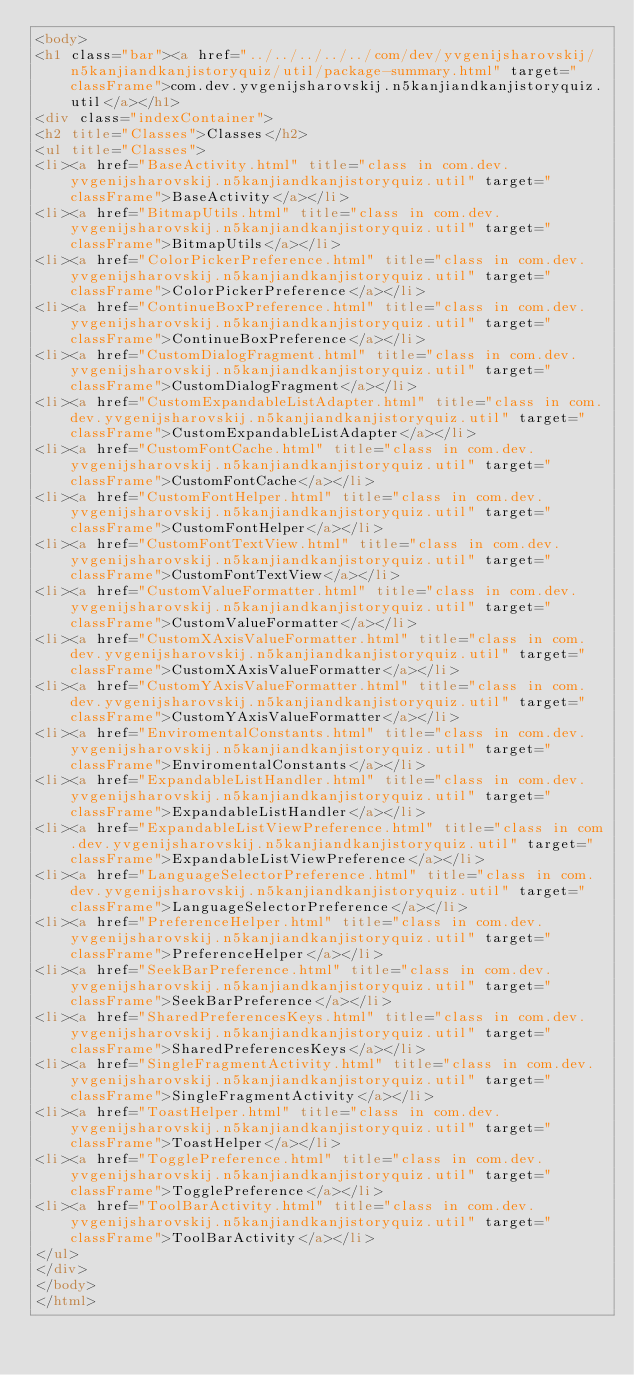Convert code to text. <code><loc_0><loc_0><loc_500><loc_500><_HTML_><body>
<h1 class="bar"><a href="../../../../../com/dev/yvgenijsharovskij/n5kanjiandkanjistoryquiz/util/package-summary.html" target="classFrame">com.dev.yvgenijsharovskij.n5kanjiandkanjistoryquiz.util</a></h1>
<div class="indexContainer">
<h2 title="Classes">Classes</h2>
<ul title="Classes">
<li><a href="BaseActivity.html" title="class in com.dev.yvgenijsharovskij.n5kanjiandkanjistoryquiz.util" target="classFrame">BaseActivity</a></li>
<li><a href="BitmapUtils.html" title="class in com.dev.yvgenijsharovskij.n5kanjiandkanjistoryquiz.util" target="classFrame">BitmapUtils</a></li>
<li><a href="ColorPickerPreference.html" title="class in com.dev.yvgenijsharovskij.n5kanjiandkanjistoryquiz.util" target="classFrame">ColorPickerPreference</a></li>
<li><a href="ContinueBoxPreference.html" title="class in com.dev.yvgenijsharovskij.n5kanjiandkanjistoryquiz.util" target="classFrame">ContinueBoxPreference</a></li>
<li><a href="CustomDialogFragment.html" title="class in com.dev.yvgenijsharovskij.n5kanjiandkanjistoryquiz.util" target="classFrame">CustomDialogFragment</a></li>
<li><a href="CustomExpandableListAdapter.html" title="class in com.dev.yvgenijsharovskij.n5kanjiandkanjistoryquiz.util" target="classFrame">CustomExpandableListAdapter</a></li>
<li><a href="CustomFontCache.html" title="class in com.dev.yvgenijsharovskij.n5kanjiandkanjistoryquiz.util" target="classFrame">CustomFontCache</a></li>
<li><a href="CustomFontHelper.html" title="class in com.dev.yvgenijsharovskij.n5kanjiandkanjistoryquiz.util" target="classFrame">CustomFontHelper</a></li>
<li><a href="CustomFontTextView.html" title="class in com.dev.yvgenijsharovskij.n5kanjiandkanjistoryquiz.util" target="classFrame">CustomFontTextView</a></li>
<li><a href="CustomValueFormatter.html" title="class in com.dev.yvgenijsharovskij.n5kanjiandkanjistoryquiz.util" target="classFrame">CustomValueFormatter</a></li>
<li><a href="CustomXAxisValueFormatter.html" title="class in com.dev.yvgenijsharovskij.n5kanjiandkanjistoryquiz.util" target="classFrame">CustomXAxisValueFormatter</a></li>
<li><a href="CustomYAxisValueFormatter.html" title="class in com.dev.yvgenijsharovskij.n5kanjiandkanjistoryquiz.util" target="classFrame">CustomYAxisValueFormatter</a></li>
<li><a href="EnviromentalConstants.html" title="class in com.dev.yvgenijsharovskij.n5kanjiandkanjistoryquiz.util" target="classFrame">EnviromentalConstants</a></li>
<li><a href="ExpandableListHandler.html" title="class in com.dev.yvgenijsharovskij.n5kanjiandkanjistoryquiz.util" target="classFrame">ExpandableListHandler</a></li>
<li><a href="ExpandableListViewPreference.html" title="class in com.dev.yvgenijsharovskij.n5kanjiandkanjistoryquiz.util" target="classFrame">ExpandableListViewPreference</a></li>
<li><a href="LanguageSelectorPreference.html" title="class in com.dev.yvgenijsharovskij.n5kanjiandkanjistoryquiz.util" target="classFrame">LanguageSelectorPreference</a></li>
<li><a href="PreferenceHelper.html" title="class in com.dev.yvgenijsharovskij.n5kanjiandkanjistoryquiz.util" target="classFrame">PreferenceHelper</a></li>
<li><a href="SeekBarPreference.html" title="class in com.dev.yvgenijsharovskij.n5kanjiandkanjistoryquiz.util" target="classFrame">SeekBarPreference</a></li>
<li><a href="SharedPreferencesKeys.html" title="class in com.dev.yvgenijsharovskij.n5kanjiandkanjistoryquiz.util" target="classFrame">SharedPreferencesKeys</a></li>
<li><a href="SingleFragmentActivity.html" title="class in com.dev.yvgenijsharovskij.n5kanjiandkanjistoryquiz.util" target="classFrame">SingleFragmentActivity</a></li>
<li><a href="ToastHelper.html" title="class in com.dev.yvgenijsharovskij.n5kanjiandkanjistoryquiz.util" target="classFrame">ToastHelper</a></li>
<li><a href="TogglePreference.html" title="class in com.dev.yvgenijsharovskij.n5kanjiandkanjistoryquiz.util" target="classFrame">TogglePreference</a></li>
<li><a href="ToolBarActivity.html" title="class in com.dev.yvgenijsharovskij.n5kanjiandkanjistoryquiz.util" target="classFrame">ToolBarActivity</a></li>
</ul>
</div>
</body>
</html>
</code> 